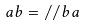Convert formula to latex. <formula><loc_0><loc_0><loc_500><loc_500>a b = / / b a</formula> 